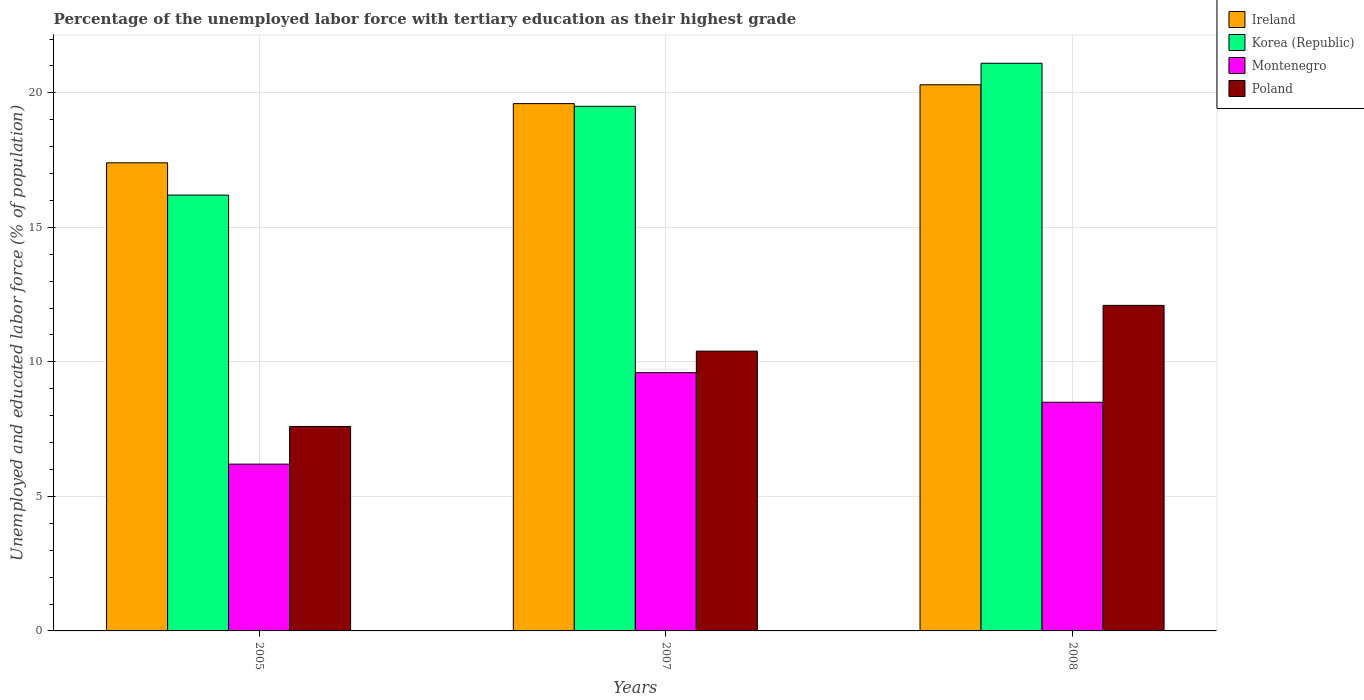How many groups of bars are there?
Give a very brief answer. 3. How many bars are there on the 1st tick from the left?
Keep it short and to the point. 4. What is the label of the 1st group of bars from the left?
Your response must be concise. 2005. What is the percentage of the unemployed labor force with tertiary education in Korea (Republic) in 2005?
Offer a very short reply. 16.2. Across all years, what is the maximum percentage of the unemployed labor force with tertiary education in Montenegro?
Offer a very short reply. 9.6. Across all years, what is the minimum percentage of the unemployed labor force with tertiary education in Montenegro?
Offer a very short reply. 6.2. What is the total percentage of the unemployed labor force with tertiary education in Poland in the graph?
Offer a terse response. 30.1. What is the difference between the percentage of the unemployed labor force with tertiary education in Montenegro in 2005 and that in 2008?
Your answer should be compact. -2.3. What is the difference between the percentage of the unemployed labor force with tertiary education in Ireland in 2007 and the percentage of the unemployed labor force with tertiary education in Montenegro in 2005?
Offer a very short reply. 13.4. What is the average percentage of the unemployed labor force with tertiary education in Poland per year?
Make the answer very short. 10.03. In the year 2005, what is the difference between the percentage of the unemployed labor force with tertiary education in Poland and percentage of the unemployed labor force with tertiary education in Korea (Republic)?
Offer a very short reply. -8.6. In how many years, is the percentage of the unemployed labor force with tertiary education in Ireland greater than 3 %?
Ensure brevity in your answer.  3. What is the ratio of the percentage of the unemployed labor force with tertiary education in Korea (Republic) in 2005 to that in 2008?
Your answer should be compact. 0.77. What is the difference between the highest and the second highest percentage of the unemployed labor force with tertiary education in Poland?
Your response must be concise. 1.7. What is the difference between the highest and the lowest percentage of the unemployed labor force with tertiary education in Poland?
Give a very brief answer. 4.5. In how many years, is the percentage of the unemployed labor force with tertiary education in Montenegro greater than the average percentage of the unemployed labor force with tertiary education in Montenegro taken over all years?
Provide a short and direct response. 2. Is the sum of the percentage of the unemployed labor force with tertiary education in Montenegro in 2007 and 2008 greater than the maximum percentage of the unemployed labor force with tertiary education in Korea (Republic) across all years?
Offer a very short reply. No. What does the 3rd bar from the left in 2005 represents?
Provide a short and direct response. Montenegro. What does the 1st bar from the right in 2007 represents?
Make the answer very short. Poland. Are all the bars in the graph horizontal?
Ensure brevity in your answer.  No. How many years are there in the graph?
Your answer should be very brief. 3. What is the difference between two consecutive major ticks on the Y-axis?
Your answer should be compact. 5. Are the values on the major ticks of Y-axis written in scientific E-notation?
Give a very brief answer. No. Does the graph contain grids?
Make the answer very short. Yes. Where does the legend appear in the graph?
Ensure brevity in your answer.  Top right. How many legend labels are there?
Make the answer very short. 4. What is the title of the graph?
Keep it short and to the point. Percentage of the unemployed labor force with tertiary education as their highest grade. What is the label or title of the X-axis?
Make the answer very short. Years. What is the label or title of the Y-axis?
Keep it short and to the point. Unemployed and educated labor force (% of population). What is the Unemployed and educated labor force (% of population) of Ireland in 2005?
Provide a short and direct response. 17.4. What is the Unemployed and educated labor force (% of population) in Korea (Republic) in 2005?
Your answer should be compact. 16.2. What is the Unemployed and educated labor force (% of population) of Montenegro in 2005?
Offer a terse response. 6.2. What is the Unemployed and educated labor force (% of population) in Poland in 2005?
Ensure brevity in your answer.  7.6. What is the Unemployed and educated labor force (% of population) in Ireland in 2007?
Ensure brevity in your answer.  19.6. What is the Unemployed and educated labor force (% of population) in Korea (Republic) in 2007?
Give a very brief answer. 19.5. What is the Unemployed and educated labor force (% of population) in Montenegro in 2007?
Keep it short and to the point. 9.6. What is the Unemployed and educated labor force (% of population) of Poland in 2007?
Give a very brief answer. 10.4. What is the Unemployed and educated labor force (% of population) of Ireland in 2008?
Provide a short and direct response. 20.3. What is the Unemployed and educated labor force (% of population) in Korea (Republic) in 2008?
Offer a very short reply. 21.1. What is the Unemployed and educated labor force (% of population) of Poland in 2008?
Offer a very short reply. 12.1. Across all years, what is the maximum Unemployed and educated labor force (% of population) in Ireland?
Your answer should be very brief. 20.3. Across all years, what is the maximum Unemployed and educated labor force (% of population) of Korea (Republic)?
Make the answer very short. 21.1. Across all years, what is the maximum Unemployed and educated labor force (% of population) in Montenegro?
Offer a terse response. 9.6. Across all years, what is the maximum Unemployed and educated labor force (% of population) in Poland?
Your response must be concise. 12.1. Across all years, what is the minimum Unemployed and educated labor force (% of population) in Ireland?
Offer a terse response. 17.4. Across all years, what is the minimum Unemployed and educated labor force (% of population) of Korea (Republic)?
Make the answer very short. 16.2. Across all years, what is the minimum Unemployed and educated labor force (% of population) in Montenegro?
Provide a short and direct response. 6.2. Across all years, what is the minimum Unemployed and educated labor force (% of population) in Poland?
Your response must be concise. 7.6. What is the total Unemployed and educated labor force (% of population) of Ireland in the graph?
Your response must be concise. 57.3. What is the total Unemployed and educated labor force (% of population) in Korea (Republic) in the graph?
Keep it short and to the point. 56.8. What is the total Unemployed and educated labor force (% of population) of Montenegro in the graph?
Provide a succinct answer. 24.3. What is the total Unemployed and educated labor force (% of population) in Poland in the graph?
Make the answer very short. 30.1. What is the difference between the Unemployed and educated labor force (% of population) in Korea (Republic) in 2005 and that in 2007?
Provide a short and direct response. -3.3. What is the difference between the Unemployed and educated labor force (% of population) of Montenegro in 2005 and that in 2007?
Your answer should be compact. -3.4. What is the difference between the Unemployed and educated labor force (% of population) of Ireland in 2005 and that in 2008?
Offer a very short reply. -2.9. What is the difference between the Unemployed and educated labor force (% of population) of Korea (Republic) in 2005 and that in 2008?
Your answer should be compact. -4.9. What is the difference between the Unemployed and educated labor force (% of population) of Korea (Republic) in 2007 and that in 2008?
Your answer should be very brief. -1.6. What is the difference between the Unemployed and educated labor force (% of population) in Montenegro in 2007 and that in 2008?
Offer a very short reply. 1.1. What is the difference between the Unemployed and educated labor force (% of population) of Ireland in 2005 and the Unemployed and educated labor force (% of population) of Korea (Republic) in 2007?
Provide a succinct answer. -2.1. What is the difference between the Unemployed and educated labor force (% of population) in Ireland in 2005 and the Unemployed and educated labor force (% of population) in Poland in 2007?
Provide a succinct answer. 7. What is the difference between the Unemployed and educated labor force (% of population) in Korea (Republic) in 2005 and the Unemployed and educated labor force (% of population) in Montenegro in 2007?
Your response must be concise. 6.6. What is the difference between the Unemployed and educated labor force (% of population) of Ireland in 2005 and the Unemployed and educated labor force (% of population) of Montenegro in 2008?
Provide a succinct answer. 8.9. What is the difference between the Unemployed and educated labor force (% of population) in Korea (Republic) in 2005 and the Unemployed and educated labor force (% of population) in Montenegro in 2008?
Keep it short and to the point. 7.7. What is the difference between the Unemployed and educated labor force (% of population) in Korea (Republic) in 2005 and the Unemployed and educated labor force (% of population) in Poland in 2008?
Your answer should be compact. 4.1. What is the difference between the Unemployed and educated labor force (% of population) in Korea (Republic) in 2007 and the Unemployed and educated labor force (% of population) in Poland in 2008?
Keep it short and to the point. 7.4. What is the difference between the Unemployed and educated labor force (% of population) in Montenegro in 2007 and the Unemployed and educated labor force (% of population) in Poland in 2008?
Your answer should be very brief. -2.5. What is the average Unemployed and educated labor force (% of population) in Ireland per year?
Keep it short and to the point. 19.1. What is the average Unemployed and educated labor force (% of population) of Korea (Republic) per year?
Give a very brief answer. 18.93. What is the average Unemployed and educated labor force (% of population) in Poland per year?
Ensure brevity in your answer.  10.03. In the year 2005, what is the difference between the Unemployed and educated labor force (% of population) in Ireland and Unemployed and educated labor force (% of population) in Poland?
Ensure brevity in your answer.  9.8. In the year 2005, what is the difference between the Unemployed and educated labor force (% of population) of Montenegro and Unemployed and educated labor force (% of population) of Poland?
Offer a very short reply. -1.4. In the year 2007, what is the difference between the Unemployed and educated labor force (% of population) in Korea (Republic) and Unemployed and educated labor force (% of population) in Poland?
Offer a very short reply. 9.1. In the year 2007, what is the difference between the Unemployed and educated labor force (% of population) of Montenegro and Unemployed and educated labor force (% of population) of Poland?
Keep it short and to the point. -0.8. In the year 2008, what is the difference between the Unemployed and educated labor force (% of population) in Ireland and Unemployed and educated labor force (% of population) in Korea (Republic)?
Make the answer very short. -0.8. In the year 2008, what is the difference between the Unemployed and educated labor force (% of population) of Montenegro and Unemployed and educated labor force (% of population) of Poland?
Your answer should be very brief. -3.6. What is the ratio of the Unemployed and educated labor force (% of population) of Ireland in 2005 to that in 2007?
Your answer should be compact. 0.89. What is the ratio of the Unemployed and educated labor force (% of population) in Korea (Republic) in 2005 to that in 2007?
Provide a short and direct response. 0.83. What is the ratio of the Unemployed and educated labor force (% of population) of Montenegro in 2005 to that in 2007?
Your answer should be very brief. 0.65. What is the ratio of the Unemployed and educated labor force (% of population) of Poland in 2005 to that in 2007?
Provide a succinct answer. 0.73. What is the ratio of the Unemployed and educated labor force (% of population) of Ireland in 2005 to that in 2008?
Make the answer very short. 0.86. What is the ratio of the Unemployed and educated labor force (% of population) of Korea (Republic) in 2005 to that in 2008?
Provide a succinct answer. 0.77. What is the ratio of the Unemployed and educated labor force (% of population) in Montenegro in 2005 to that in 2008?
Keep it short and to the point. 0.73. What is the ratio of the Unemployed and educated labor force (% of population) of Poland in 2005 to that in 2008?
Keep it short and to the point. 0.63. What is the ratio of the Unemployed and educated labor force (% of population) of Ireland in 2007 to that in 2008?
Your answer should be very brief. 0.97. What is the ratio of the Unemployed and educated labor force (% of population) in Korea (Republic) in 2007 to that in 2008?
Keep it short and to the point. 0.92. What is the ratio of the Unemployed and educated labor force (% of population) of Montenegro in 2007 to that in 2008?
Provide a succinct answer. 1.13. What is the ratio of the Unemployed and educated labor force (% of population) in Poland in 2007 to that in 2008?
Offer a terse response. 0.86. What is the difference between the highest and the second highest Unemployed and educated labor force (% of population) of Korea (Republic)?
Your response must be concise. 1.6. What is the difference between the highest and the second highest Unemployed and educated labor force (% of population) in Montenegro?
Your answer should be very brief. 1.1. What is the difference between the highest and the lowest Unemployed and educated labor force (% of population) in Poland?
Provide a succinct answer. 4.5. 